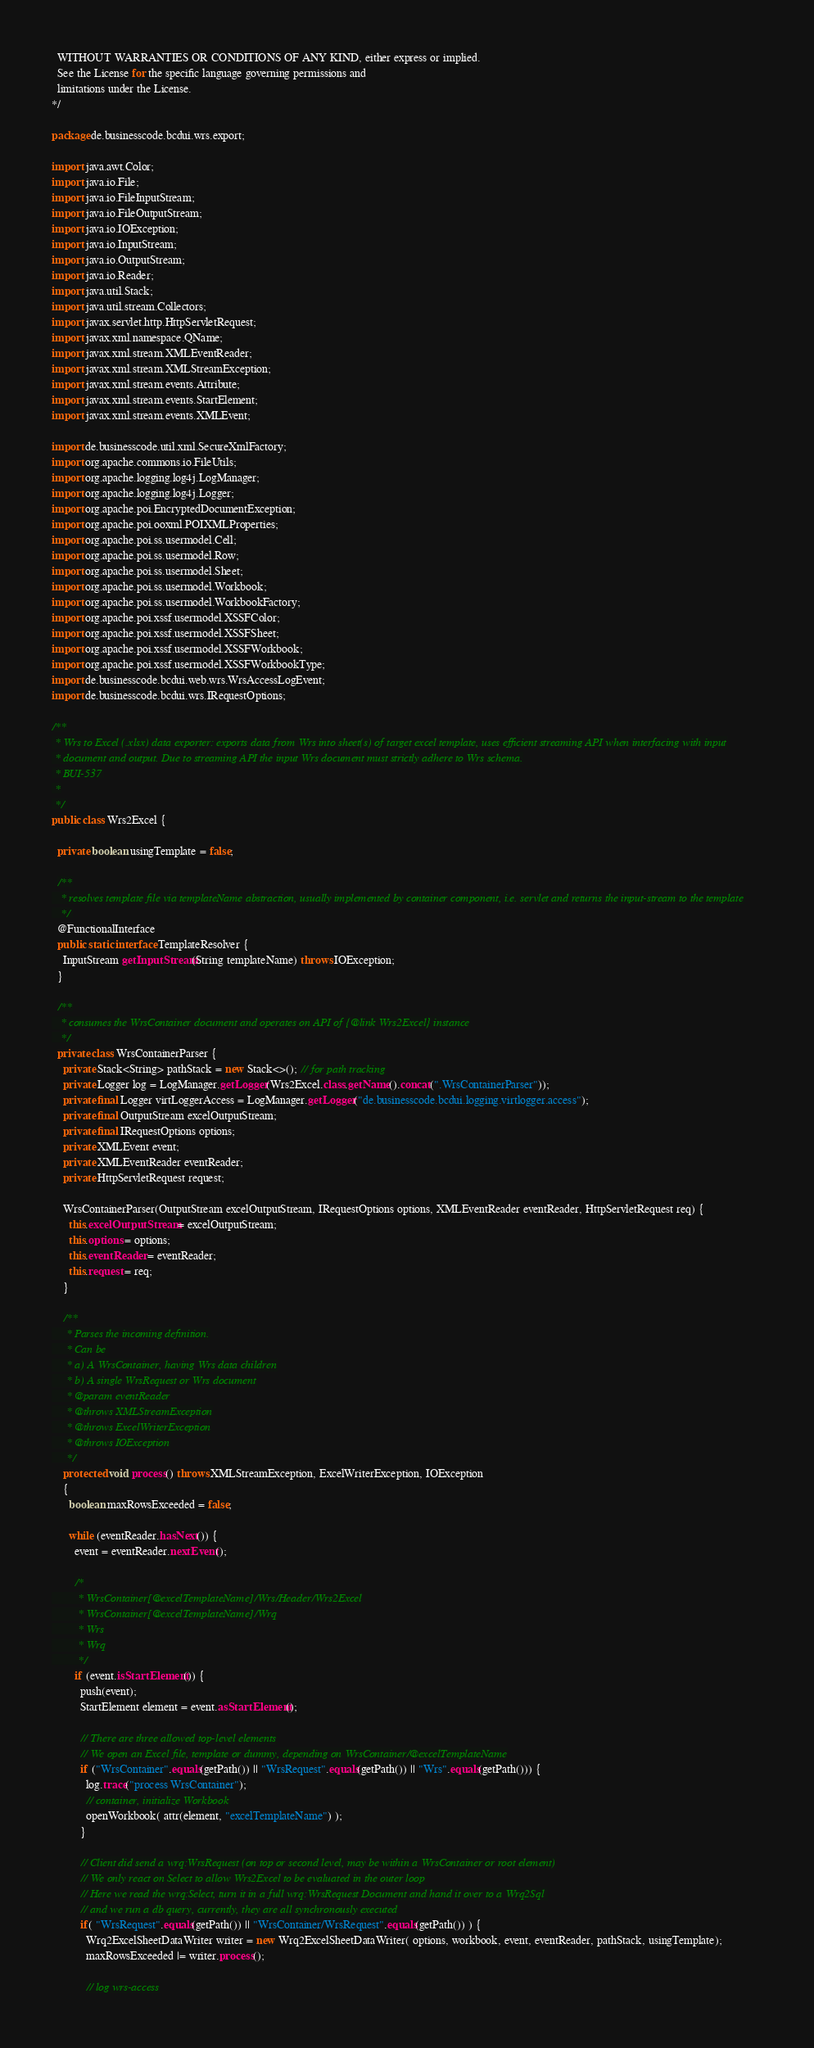<code> <loc_0><loc_0><loc_500><loc_500><_Java_>  WITHOUT WARRANTIES OR CONDITIONS OF ANY KIND, either express or implied.
  See the License for the specific language governing permissions and
  limitations under the License.
*/

package de.businesscode.bcdui.wrs.export;

import java.awt.Color;
import java.io.File;
import java.io.FileInputStream;
import java.io.FileOutputStream;
import java.io.IOException;
import java.io.InputStream;
import java.io.OutputStream;
import java.io.Reader;
import java.util.Stack;
import java.util.stream.Collectors;
import javax.servlet.http.HttpServletRequest;
import javax.xml.namespace.QName;
import javax.xml.stream.XMLEventReader;
import javax.xml.stream.XMLStreamException;
import javax.xml.stream.events.Attribute;
import javax.xml.stream.events.StartElement;
import javax.xml.stream.events.XMLEvent;

import de.businesscode.util.xml.SecureXmlFactory;
import org.apache.commons.io.FileUtils;
import org.apache.logging.log4j.LogManager;
import org.apache.logging.log4j.Logger;
import org.apache.poi.EncryptedDocumentException;
import org.apache.poi.ooxml.POIXMLProperties;
import org.apache.poi.ss.usermodel.Cell;
import org.apache.poi.ss.usermodel.Row;
import org.apache.poi.ss.usermodel.Sheet;
import org.apache.poi.ss.usermodel.Workbook;
import org.apache.poi.ss.usermodel.WorkbookFactory;
import org.apache.poi.xssf.usermodel.XSSFColor;
import org.apache.poi.xssf.usermodel.XSSFSheet;
import org.apache.poi.xssf.usermodel.XSSFWorkbook;
import org.apache.poi.xssf.usermodel.XSSFWorkbookType;
import de.businesscode.bcdui.web.wrs.WrsAccessLogEvent;
import de.businesscode.bcdui.wrs.IRequestOptions;

/**
 * Wrs to Excel (.xlsx) data exporter: exports data from Wrs into sheet(s) of target excel template, uses efficient streaming API when interfacing with input
 * document and output. Due to streaming API the input Wrs document must strictly adhere to Wrs schema.
 * BUI-537
 *
 */
public class Wrs2Excel {

  private boolean usingTemplate = false;
  
  /**
   * resolves template file via templateName abstraction, usually implemented by container component, i.e. servlet and returns the input-stream to the template
   */
  @FunctionalInterface
  public static interface TemplateResolver {
    InputStream getInputStream(String templateName) throws IOException;
  }

  /**
   * consumes the WrsContainer document and operates on API of {@link Wrs2Excel} instance
   */
  private class WrsContainerParser {
    private Stack<String> pathStack = new Stack<>(); // for path tracking
    private Logger log = LogManager.getLogger(Wrs2Excel.class.getName().concat(".WrsContainerParser"));
    private final Logger virtLoggerAccess = LogManager.getLogger("de.businesscode.bcdui.logging.virtlogger.access");
    private final OutputStream excelOutputStream;
    private final IRequestOptions options;
    private XMLEvent event;
    private XMLEventReader eventReader;
    private HttpServletRequest request;

    WrsContainerParser(OutputStream excelOutputStream, IRequestOptions options, XMLEventReader eventReader, HttpServletRequest req) {
      this.excelOutputStream = excelOutputStream;
      this.options = options;
      this.eventReader = eventReader;
      this.request = req;
    }

    /**
     * Parses the incoming definition.
     * Can be 
     * a) A WrsContainer, having Wrs data children
     * b) A single WrsRequest or Wrs document
     * @param eventReader
     * @throws XMLStreamException
     * @throws ExcelWriterException
     * @throws IOException
     */
    protected void process() throws XMLStreamException, ExcelWriterException, IOException 
    {
      boolean maxRowsExceeded = false;

      while (eventReader.hasNext()) {
        event = eventReader.nextEvent();

        /*
         * WrsContainer[@excelTemplateName]/Wrs/Header/Wrs2Excel
         * WrsContainer[@excelTemplateName]/Wrq
         * Wrs
         * Wrq
         */
        if (event.isStartElement()) {
          push(event);
          StartElement element = event.asStartElement();

          // There are three allowed top-level elements
          // We open an Excel file, template or dummy, depending on WrsContainer/@excelTemplateName
          if ("WrsContainer".equals(getPath()) || "WrsRequest".equals(getPath()) || "Wrs".equals(getPath())) {
            log.trace("process WrsContainer");
            // container, initialize Workbook
            openWorkbook( attr(element, "excelTemplateName") );
          }

          // Client did send a wrq:WrsRequest (on top or second level, may be within a WrsContainer or root element)
          // We only react on Select to allow Wrs2Excel to be evaluated in the outer loop
          // Here we read the wrq:Select, turn it in a full wrq:WrsRequest Document and hand it over to a Wrq2Sql 
          // and we run a db query, currently, they are all synchronously executed
          if( "WrsRequest".equals(getPath()) || "WrsContainer/WrsRequest".equals(getPath()) ) {
            Wrq2ExcelSheetDataWriter writer = new Wrq2ExcelSheetDataWriter( options, workbook, event, eventReader, pathStack, usingTemplate);
            maxRowsExceeded |= writer.process();

            // log wrs-access</code> 